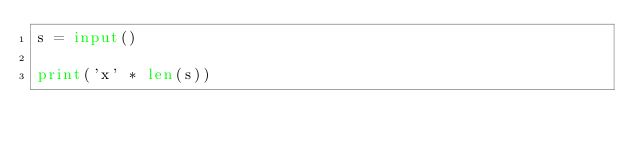<code> <loc_0><loc_0><loc_500><loc_500><_Python_>s = input()

print('x' * len(s))</code> 